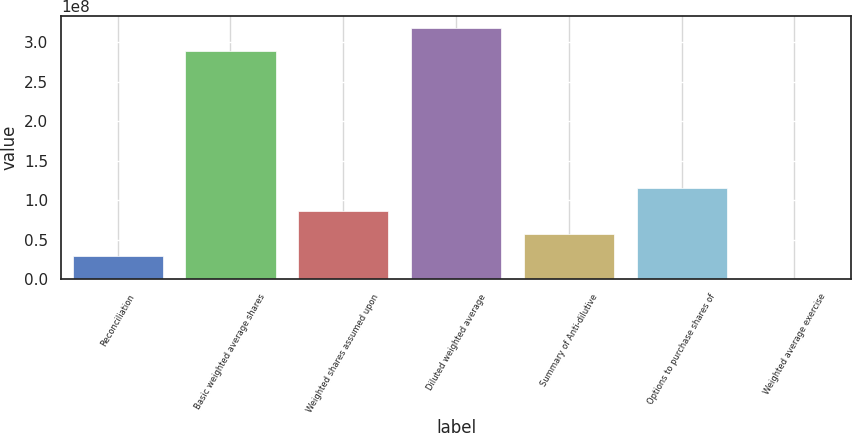Convert chart to OTSL. <chart><loc_0><loc_0><loc_500><loc_500><bar_chart><fcel>Reconciliation<fcel>Basic weighted average shares<fcel>Weighted shares assumed upon<fcel>Diluted weighted average<fcel>Summary of Anti-dilutive<fcel>Options to purchase shares of<fcel>Weighted average exercise<nl><fcel>2.89158e+07<fcel>2.8895e+08<fcel>8.67473e+07<fcel>3.17865e+08<fcel>5.78315e+07<fcel>1.15663e+08<fcel>50.09<nl></chart> 